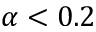<formula> <loc_0><loc_0><loc_500><loc_500>\alpha < 0 . 2</formula> 